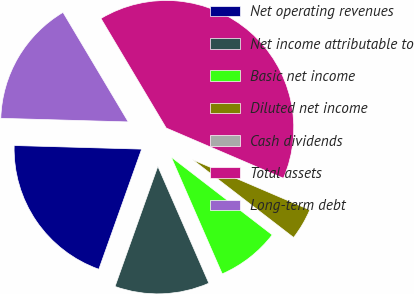Convert chart to OTSL. <chart><loc_0><loc_0><loc_500><loc_500><pie_chart><fcel>Net operating revenues<fcel>Net income attributable to<fcel>Basic net income<fcel>Diluted net income<fcel>Cash dividends<fcel>Total assets<fcel>Long-term debt<nl><fcel>20.0%<fcel>12.0%<fcel>8.0%<fcel>4.0%<fcel>0.0%<fcel>40.0%<fcel>16.0%<nl></chart> 